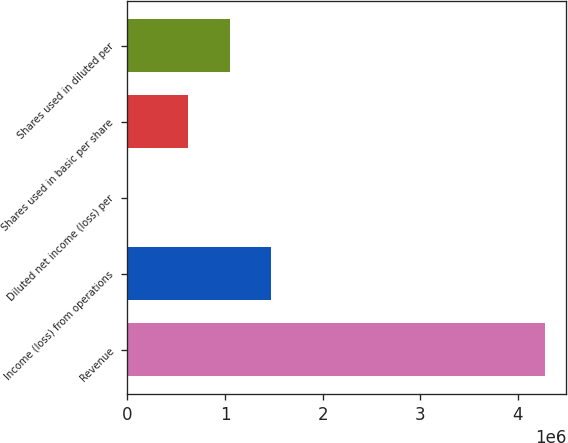Convert chart. <chart><loc_0><loc_0><loc_500><loc_500><bar_chart><fcel>Revenue<fcel>Income (loss) from operations<fcel>Diluted net income (loss) per<fcel>Shares used in basic per share<fcel>Shares used in diluted per<nl><fcel>4.28016e+06<fcel>1.47536e+06<fcel>0.9<fcel>619324<fcel>1.04734e+06<nl></chart> 